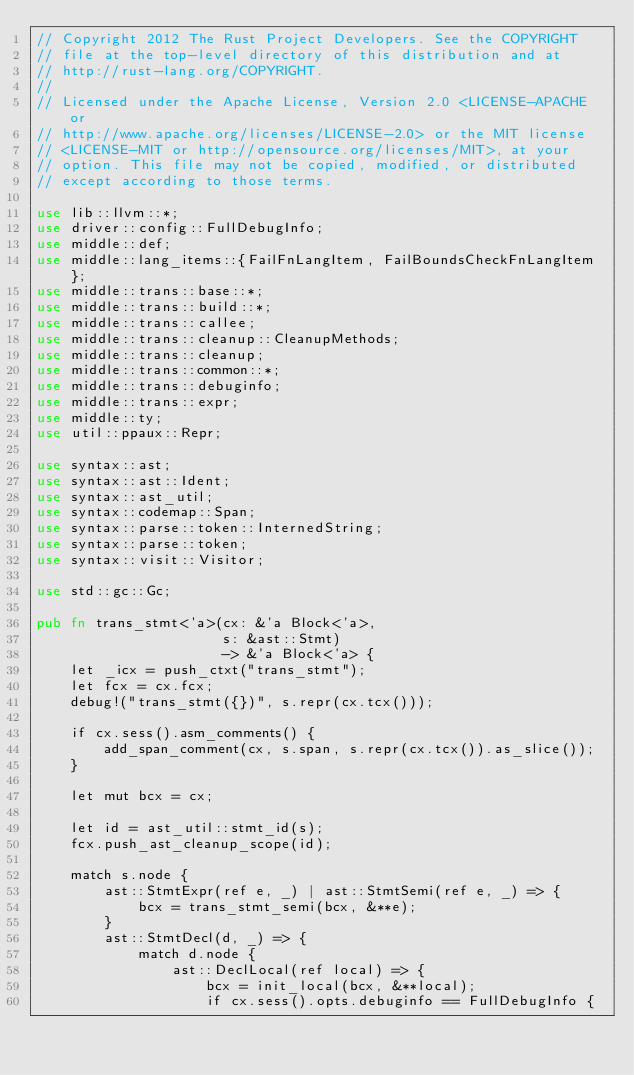Convert code to text. <code><loc_0><loc_0><loc_500><loc_500><_Rust_>// Copyright 2012 The Rust Project Developers. See the COPYRIGHT
// file at the top-level directory of this distribution and at
// http://rust-lang.org/COPYRIGHT.
//
// Licensed under the Apache License, Version 2.0 <LICENSE-APACHE or
// http://www.apache.org/licenses/LICENSE-2.0> or the MIT license
// <LICENSE-MIT or http://opensource.org/licenses/MIT>, at your
// option. This file may not be copied, modified, or distributed
// except according to those terms.

use lib::llvm::*;
use driver::config::FullDebugInfo;
use middle::def;
use middle::lang_items::{FailFnLangItem, FailBoundsCheckFnLangItem};
use middle::trans::base::*;
use middle::trans::build::*;
use middle::trans::callee;
use middle::trans::cleanup::CleanupMethods;
use middle::trans::cleanup;
use middle::trans::common::*;
use middle::trans::debuginfo;
use middle::trans::expr;
use middle::ty;
use util::ppaux::Repr;

use syntax::ast;
use syntax::ast::Ident;
use syntax::ast_util;
use syntax::codemap::Span;
use syntax::parse::token::InternedString;
use syntax::parse::token;
use syntax::visit::Visitor;

use std::gc::Gc;

pub fn trans_stmt<'a>(cx: &'a Block<'a>,
                      s: &ast::Stmt)
                      -> &'a Block<'a> {
    let _icx = push_ctxt("trans_stmt");
    let fcx = cx.fcx;
    debug!("trans_stmt({})", s.repr(cx.tcx()));

    if cx.sess().asm_comments() {
        add_span_comment(cx, s.span, s.repr(cx.tcx()).as_slice());
    }

    let mut bcx = cx;

    let id = ast_util::stmt_id(s);
    fcx.push_ast_cleanup_scope(id);

    match s.node {
        ast::StmtExpr(ref e, _) | ast::StmtSemi(ref e, _) => {
            bcx = trans_stmt_semi(bcx, &**e);
        }
        ast::StmtDecl(d, _) => {
            match d.node {
                ast::DeclLocal(ref local) => {
                    bcx = init_local(bcx, &**local);
                    if cx.sess().opts.debuginfo == FullDebugInfo {</code> 